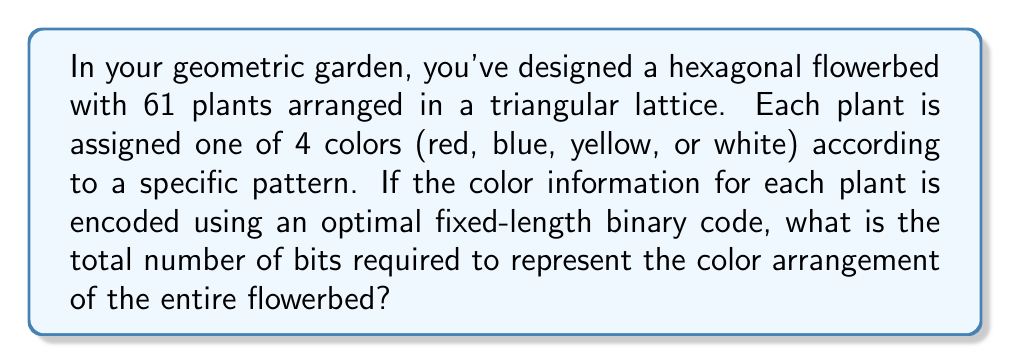Provide a solution to this math problem. To solve this problem, we need to follow these steps:

1) First, let's calculate the number of bits needed to represent each color using an optimal fixed-length binary code.

   With 4 colors, we need 2 bits per color:
   $2^2 = 4$

2) Now, we need to calculate the total number of plants in the hexagonal flowerbed.
   The hexagonal arrangement with a triangular lattice follows the centered hexagonal number sequence.
   The 61st centered hexagonal number is indeed 61 plants.

3) To calculate the total number of bits, we multiply the number of plants by the number of bits per plant:

   $61 \text{ plants} \times 2 \text{ bits/plant} = 122 \text{ bits}$

Let's visualize the hexagonal arrangement:

[asy]
unitsize(10mm);
int n = 5;
for(int i = -n; i <= n; ++i)
  for(int j = -n; j <= n; ++j)
    for(int k = -n; k <= n; ++k)
      if(i + j + k == 0)
        dot((i-j)*sqrt(3)/2, i+j);
[/asy]

This diagram shows the triangular lattice arrangement of the 61 plants in the hexagonal flowerbed.

4) Therefore, the total number of bits required to represent the color arrangement of the entire flowerbed is 122 bits.
Answer: 122 bits 